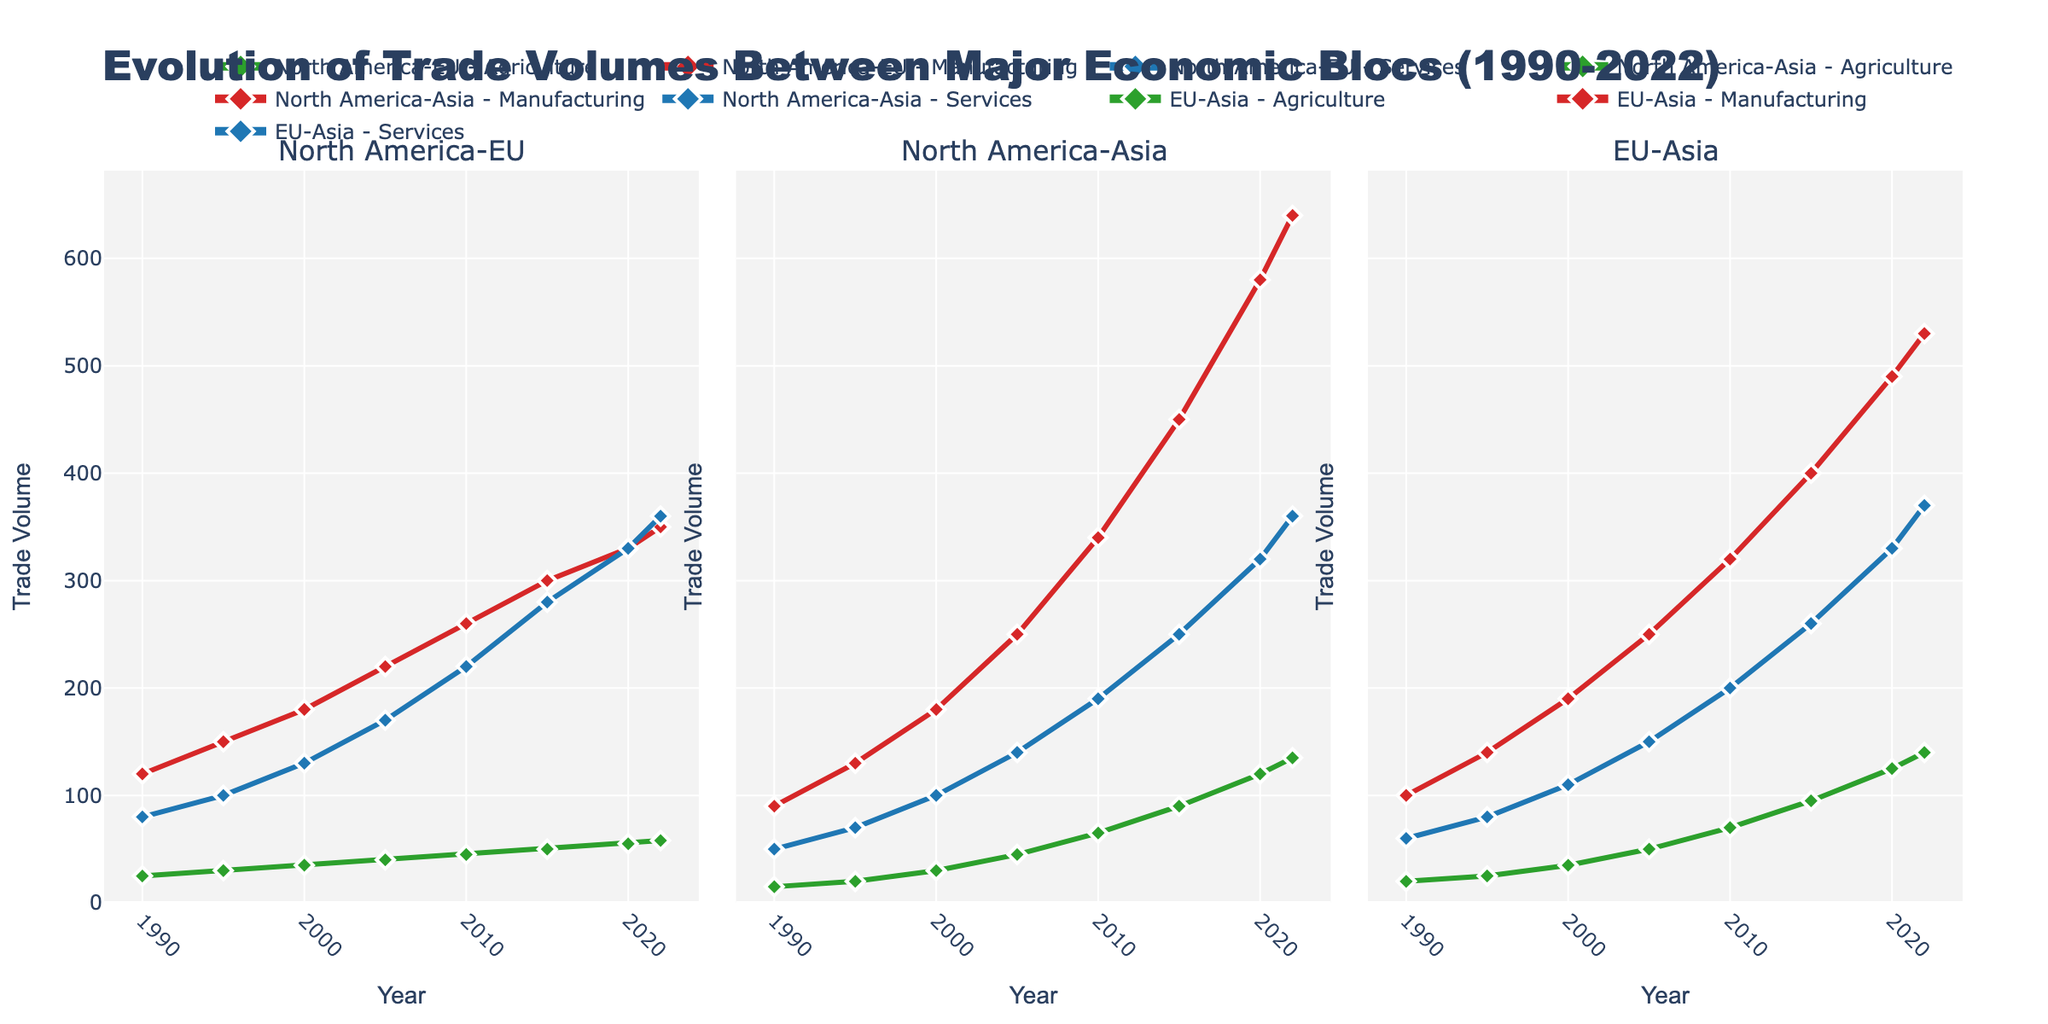What is the highest trade volume recorded in North America-Asia Agriculture? The highest value in the North America-Asia Agriculture data series is 135 in the year 2022. By looking at the line chart, we see the peak point lies at the end of the timeline in the subplot for North America-Asia.
Answer: 135 Which economic bloc shows the greatest increase in manufacturing trade volume from 1990 to 2022? To determine the greatest increase, calculate the difference for each bloc between the initial and final years. For North America-EU Manufacturing: 350 - 120 = 230. For North America-Asia Manufacturing: 640 - 90 = 550. For EU-Asia Manufacturing: 530 - 100 = 430. North America-Asia shows the largest increase.
Answer: North America-Asia How does the trade volume of EU-Asia Services in 2015 compare to North America-EU Services in the same year? In 2015, the trade volume for EU-Asia Services is 260 and for North America-EU Services is 280. When comparing these, 260 is less than 280.
Answer: EU-Asia Services is less What is the total trade volume for North America-EU in 2005 across all product types? Sum up the volumes for Agriculture, Manufacturing, and Services in North America-EU for 2005: 40 + 220 + 170 = 430.
Answer: 430 During which year did North America-Asia Agriculture trade volume first exceed 50? By looking at the line for North America-Asia Agriculture, the volume first reaches 65 in 2010, indicating that it first exceeds 50 in this year.
Answer: 2010 In what year does the EU-Asia Agriculture trade volume double from its 1990 level? The EU-Asia Agriculture trade volume in 1990 is 20. To find when it hits 40 (double of 20), checking values in subsequent years, we see it reaches 50 in 2005.
Answer: 2005 How does the trend of North America-EU Manufacturing trade volume from 1990 to 2022 compare with EU-Asia Manufacturing in the same period? Both trade volumes show an upward trend, however, the increase for North America-EU is from 120 to 350, while EU-Asia grows from 100 to 530, indicating that EU-Asia Manufacturing trade volume grows more rapidly and ends higher.
Answer: EU-Asia increased more rapidly Is there a year where trade volume for North America-Asia Services is equal to that of EU-Asia Services? By looking at the individual points and matching the trade volumes for North America-Asia Services and EU-Asia Services, there is no year where the values are equal.
Answer: No What is the average trade volume for EU-Asia Agriculture from 1990 to 2022? Sum up all the trade volumes for EU-Asia Agriculture (20+25+35+50+70+95+125+140 = 560) and divide by the number of years (8): 560 / 8 = 70.
Answer: 70 